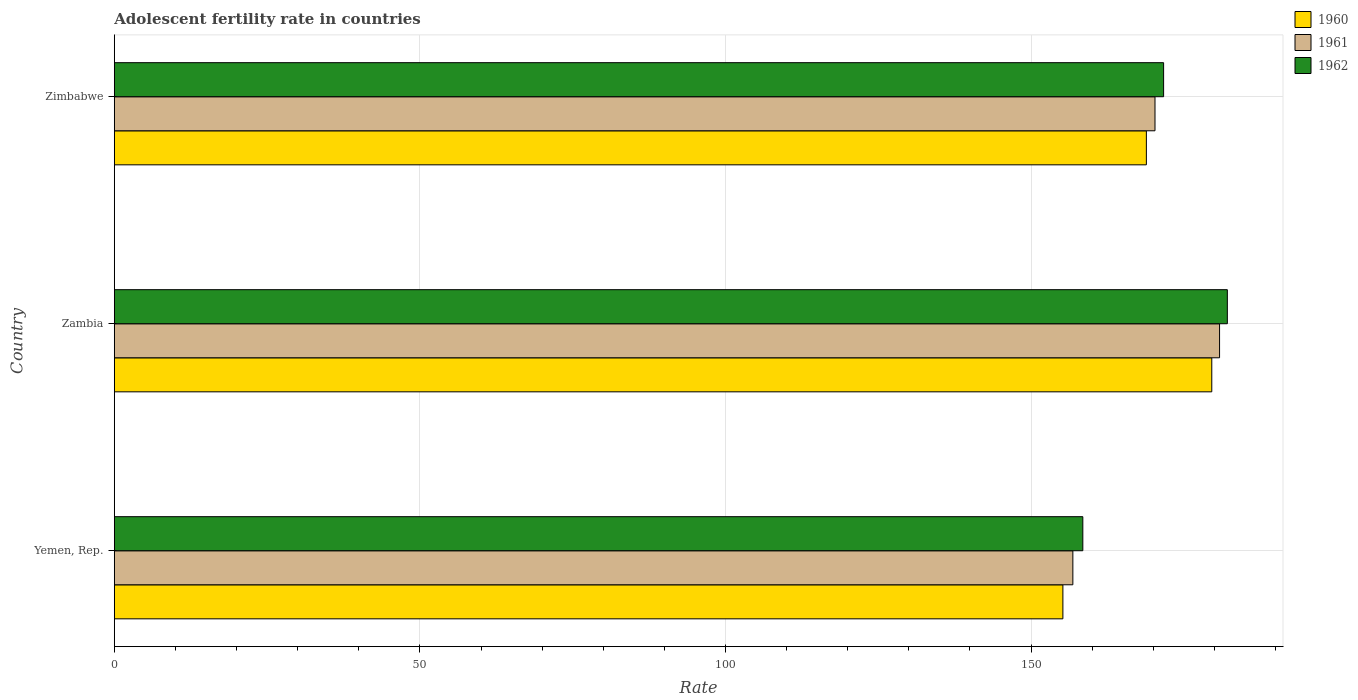How many different coloured bars are there?
Your answer should be very brief. 3. How many groups of bars are there?
Make the answer very short. 3. Are the number of bars per tick equal to the number of legend labels?
Provide a short and direct response. Yes. How many bars are there on the 3rd tick from the top?
Keep it short and to the point. 3. How many bars are there on the 3rd tick from the bottom?
Offer a terse response. 3. What is the label of the 3rd group of bars from the top?
Ensure brevity in your answer.  Yemen, Rep. In how many cases, is the number of bars for a given country not equal to the number of legend labels?
Offer a terse response. 0. What is the adolescent fertility rate in 1962 in Zimbabwe?
Provide a succinct answer. 171.7. Across all countries, what is the maximum adolescent fertility rate in 1961?
Your answer should be very brief. 180.85. Across all countries, what is the minimum adolescent fertility rate in 1960?
Offer a very short reply. 155.21. In which country was the adolescent fertility rate in 1960 maximum?
Keep it short and to the point. Zambia. In which country was the adolescent fertility rate in 1962 minimum?
Your response must be concise. Yemen, Rep. What is the total adolescent fertility rate in 1962 in the graph?
Offer a terse response. 512.29. What is the difference between the adolescent fertility rate in 1962 in Yemen, Rep. and that in Zambia?
Your response must be concise. -23.65. What is the difference between the adolescent fertility rate in 1960 in Yemen, Rep. and the adolescent fertility rate in 1961 in Zambia?
Your answer should be compact. -25.63. What is the average adolescent fertility rate in 1962 per country?
Offer a terse response. 170.76. What is the difference between the adolescent fertility rate in 1962 and adolescent fertility rate in 1961 in Zimbabwe?
Provide a succinct answer. 1.41. What is the ratio of the adolescent fertility rate in 1960 in Yemen, Rep. to that in Zimbabwe?
Ensure brevity in your answer.  0.92. Is the difference between the adolescent fertility rate in 1962 in Yemen, Rep. and Zambia greater than the difference between the adolescent fertility rate in 1961 in Yemen, Rep. and Zambia?
Provide a short and direct response. Yes. What is the difference between the highest and the second highest adolescent fertility rate in 1961?
Offer a terse response. 10.56. What is the difference between the highest and the lowest adolescent fertility rate in 1962?
Provide a succinct answer. 23.65. In how many countries, is the adolescent fertility rate in 1960 greater than the average adolescent fertility rate in 1960 taken over all countries?
Give a very brief answer. 2. Is the sum of the adolescent fertility rate in 1962 in Yemen, Rep. and Zambia greater than the maximum adolescent fertility rate in 1960 across all countries?
Ensure brevity in your answer.  Yes. What does the 1st bar from the bottom in Yemen, Rep. represents?
Give a very brief answer. 1960. How many bars are there?
Keep it short and to the point. 9. What is the difference between two consecutive major ticks on the X-axis?
Keep it short and to the point. 50. Are the values on the major ticks of X-axis written in scientific E-notation?
Your answer should be compact. No. Does the graph contain grids?
Keep it short and to the point. Yes. Where does the legend appear in the graph?
Provide a short and direct response. Top right. How are the legend labels stacked?
Provide a succinct answer. Vertical. What is the title of the graph?
Offer a terse response. Adolescent fertility rate in countries. Does "1975" appear as one of the legend labels in the graph?
Offer a very short reply. No. What is the label or title of the X-axis?
Ensure brevity in your answer.  Rate. What is the Rate in 1960 in Yemen, Rep.?
Your answer should be compact. 155.21. What is the Rate of 1961 in Yemen, Rep.?
Give a very brief answer. 156.85. What is the Rate in 1962 in Yemen, Rep.?
Your answer should be compact. 158.48. What is the Rate in 1960 in Zambia?
Your answer should be very brief. 179.58. What is the Rate in 1961 in Zambia?
Provide a short and direct response. 180.85. What is the Rate of 1962 in Zambia?
Ensure brevity in your answer.  182.12. What is the Rate in 1960 in Zimbabwe?
Ensure brevity in your answer.  168.87. What is the Rate in 1961 in Zimbabwe?
Ensure brevity in your answer.  170.28. What is the Rate in 1962 in Zimbabwe?
Your answer should be very brief. 171.7. Across all countries, what is the maximum Rate in 1960?
Provide a short and direct response. 179.58. Across all countries, what is the maximum Rate in 1961?
Your answer should be compact. 180.85. Across all countries, what is the maximum Rate in 1962?
Make the answer very short. 182.12. Across all countries, what is the minimum Rate in 1960?
Give a very brief answer. 155.21. Across all countries, what is the minimum Rate in 1961?
Your answer should be compact. 156.85. Across all countries, what is the minimum Rate of 1962?
Make the answer very short. 158.48. What is the total Rate of 1960 in the graph?
Make the answer very short. 503.66. What is the total Rate in 1961 in the graph?
Give a very brief answer. 507.98. What is the total Rate in 1962 in the graph?
Your answer should be very brief. 512.29. What is the difference between the Rate in 1960 in Yemen, Rep. and that in Zambia?
Your answer should be very brief. -24.36. What is the difference between the Rate of 1961 in Yemen, Rep. and that in Zambia?
Your answer should be compact. -24. What is the difference between the Rate in 1962 in Yemen, Rep. and that in Zambia?
Make the answer very short. -23.65. What is the difference between the Rate in 1960 in Yemen, Rep. and that in Zimbabwe?
Your response must be concise. -13.66. What is the difference between the Rate in 1961 in Yemen, Rep. and that in Zimbabwe?
Give a very brief answer. -13.44. What is the difference between the Rate in 1962 in Yemen, Rep. and that in Zimbabwe?
Give a very brief answer. -13.22. What is the difference between the Rate in 1960 in Zambia and that in Zimbabwe?
Give a very brief answer. 10.7. What is the difference between the Rate in 1961 in Zambia and that in Zimbabwe?
Provide a short and direct response. 10.56. What is the difference between the Rate in 1962 in Zambia and that in Zimbabwe?
Make the answer very short. 10.43. What is the difference between the Rate of 1960 in Yemen, Rep. and the Rate of 1961 in Zambia?
Provide a short and direct response. -25.64. What is the difference between the Rate of 1960 in Yemen, Rep. and the Rate of 1962 in Zambia?
Make the answer very short. -26.91. What is the difference between the Rate of 1961 in Yemen, Rep. and the Rate of 1962 in Zambia?
Keep it short and to the point. -25.28. What is the difference between the Rate of 1960 in Yemen, Rep. and the Rate of 1961 in Zimbabwe?
Offer a terse response. -15.07. What is the difference between the Rate in 1960 in Yemen, Rep. and the Rate in 1962 in Zimbabwe?
Your answer should be compact. -16.48. What is the difference between the Rate in 1961 in Yemen, Rep. and the Rate in 1962 in Zimbabwe?
Ensure brevity in your answer.  -14.85. What is the difference between the Rate in 1960 in Zambia and the Rate in 1961 in Zimbabwe?
Your response must be concise. 9.29. What is the difference between the Rate of 1960 in Zambia and the Rate of 1962 in Zimbabwe?
Give a very brief answer. 7.88. What is the difference between the Rate in 1961 in Zambia and the Rate in 1962 in Zimbabwe?
Your answer should be compact. 9.15. What is the average Rate of 1960 per country?
Ensure brevity in your answer.  167.89. What is the average Rate of 1961 per country?
Offer a very short reply. 169.33. What is the average Rate in 1962 per country?
Keep it short and to the point. 170.76. What is the difference between the Rate in 1960 and Rate in 1961 in Yemen, Rep.?
Your answer should be very brief. -1.63. What is the difference between the Rate in 1960 and Rate in 1962 in Yemen, Rep.?
Keep it short and to the point. -3.26. What is the difference between the Rate of 1961 and Rate of 1962 in Yemen, Rep.?
Your answer should be very brief. -1.63. What is the difference between the Rate of 1960 and Rate of 1961 in Zambia?
Your response must be concise. -1.27. What is the difference between the Rate of 1960 and Rate of 1962 in Zambia?
Make the answer very short. -2.55. What is the difference between the Rate of 1961 and Rate of 1962 in Zambia?
Make the answer very short. -1.27. What is the difference between the Rate of 1960 and Rate of 1961 in Zimbabwe?
Offer a very short reply. -1.41. What is the difference between the Rate of 1960 and Rate of 1962 in Zimbabwe?
Your answer should be very brief. -2.82. What is the difference between the Rate of 1961 and Rate of 1962 in Zimbabwe?
Offer a very short reply. -1.41. What is the ratio of the Rate of 1960 in Yemen, Rep. to that in Zambia?
Make the answer very short. 0.86. What is the ratio of the Rate of 1961 in Yemen, Rep. to that in Zambia?
Give a very brief answer. 0.87. What is the ratio of the Rate in 1962 in Yemen, Rep. to that in Zambia?
Offer a terse response. 0.87. What is the ratio of the Rate of 1960 in Yemen, Rep. to that in Zimbabwe?
Keep it short and to the point. 0.92. What is the ratio of the Rate in 1961 in Yemen, Rep. to that in Zimbabwe?
Your response must be concise. 0.92. What is the ratio of the Rate in 1962 in Yemen, Rep. to that in Zimbabwe?
Keep it short and to the point. 0.92. What is the ratio of the Rate in 1960 in Zambia to that in Zimbabwe?
Give a very brief answer. 1.06. What is the ratio of the Rate of 1961 in Zambia to that in Zimbabwe?
Your answer should be compact. 1.06. What is the ratio of the Rate of 1962 in Zambia to that in Zimbabwe?
Your answer should be very brief. 1.06. What is the difference between the highest and the second highest Rate of 1960?
Your response must be concise. 10.7. What is the difference between the highest and the second highest Rate in 1961?
Keep it short and to the point. 10.56. What is the difference between the highest and the second highest Rate in 1962?
Keep it short and to the point. 10.43. What is the difference between the highest and the lowest Rate in 1960?
Your response must be concise. 24.36. What is the difference between the highest and the lowest Rate in 1961?
Your answer should be very brief. 24. What is the difference between the highest and the lowest Rate in 1962?
Your response must be concise. 23.65. 